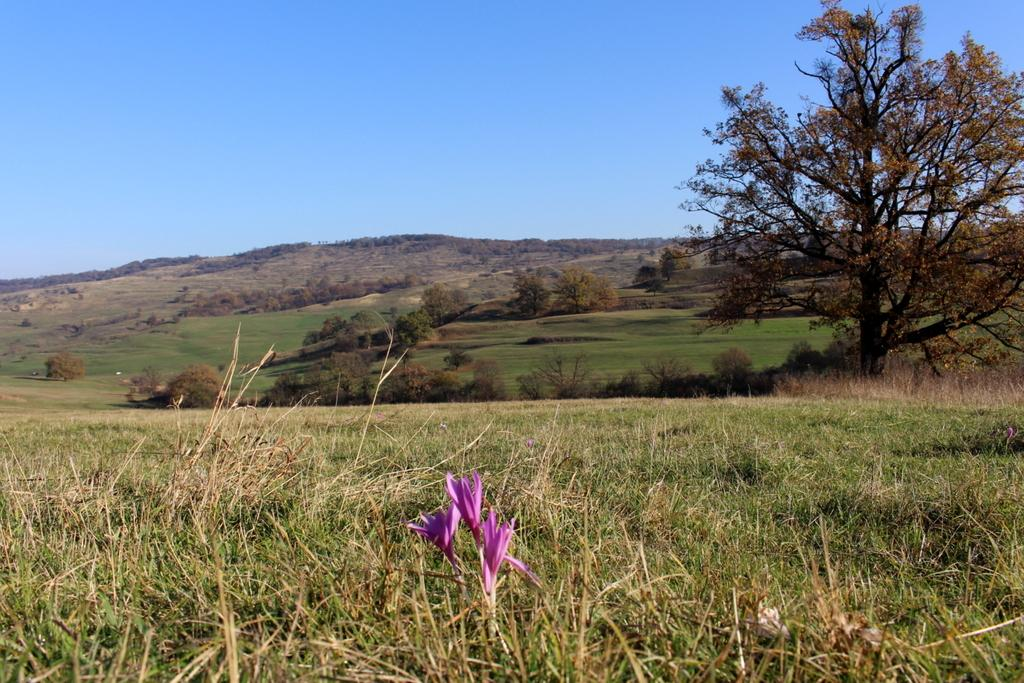What type of plants can be seen at the bottom of the image? There are flowers at the bottom side of the image. What else can be observed in the image besides the flowers? There is greenery in the image. What type of hair can be seen on the flowers in the image? There is no hair present on the flowers in the image. 